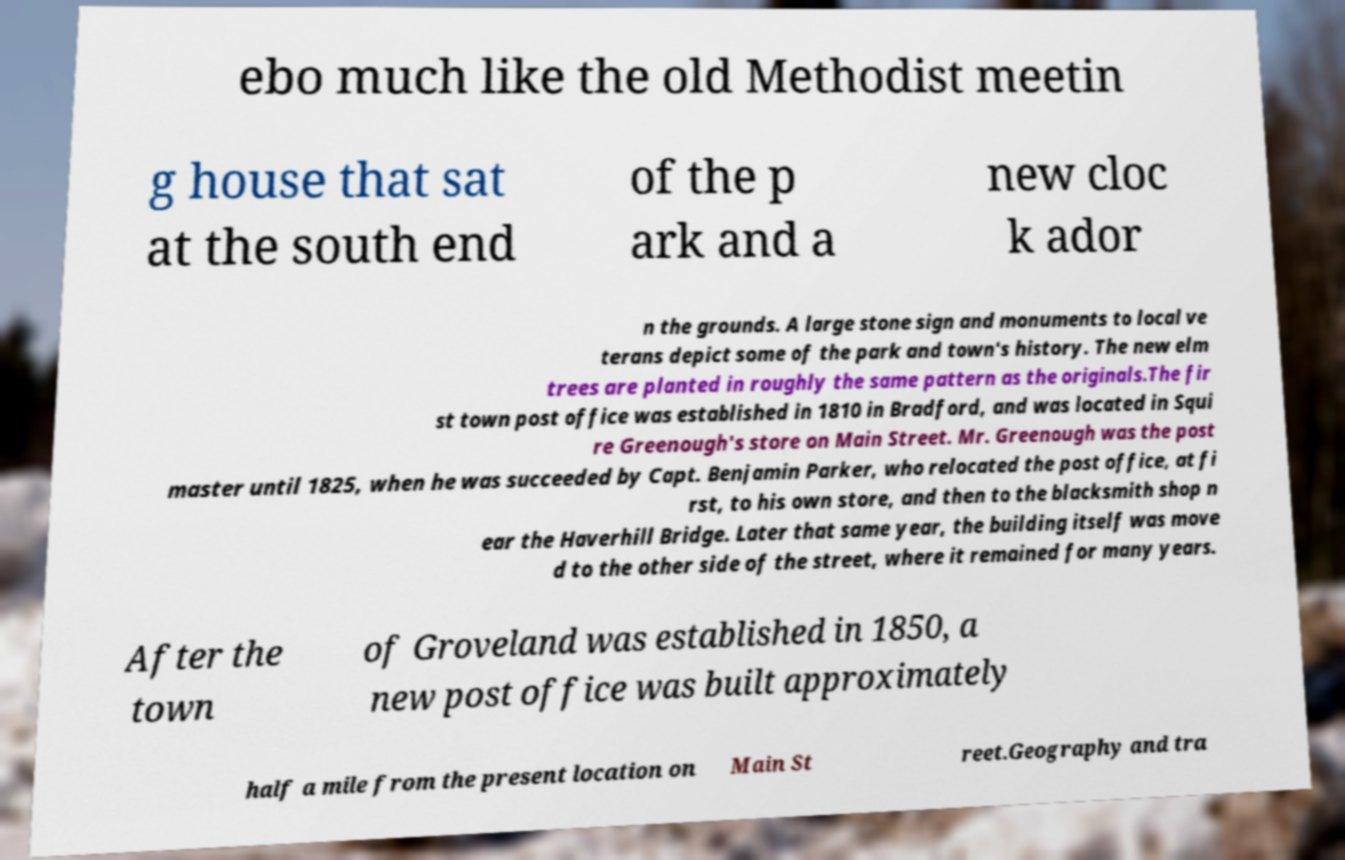What messages or text are displayed in this image? I need them in a readable, typed format. ebo much like the old Methodist meetin g house that sat at the south end of the p ark and a new cloc k ador n the grounds. A large stone sign and monuments to local ve terans depict some of the park and town's history. The new elm trees are planted in roughly the same pattern as the originals.The fir st town post office was established in 1810 in Bradford, and was located in Squi re Greenough's store on Main Street. Mr. Greenough was the post master until 1825, when he was succeeded by Capt. Benjamin Parker, who relocated the post office, at fi rst, to his own store, and then to the blacksmith shop n ear the Haverhill Bridge. Later that same year, the building itself was move d to the other side of the street, where it remained for many years. After the town of Groveland was established in 1850, a new post office was built approximately half a mile from the present location on Main St reet.Geography and tra 